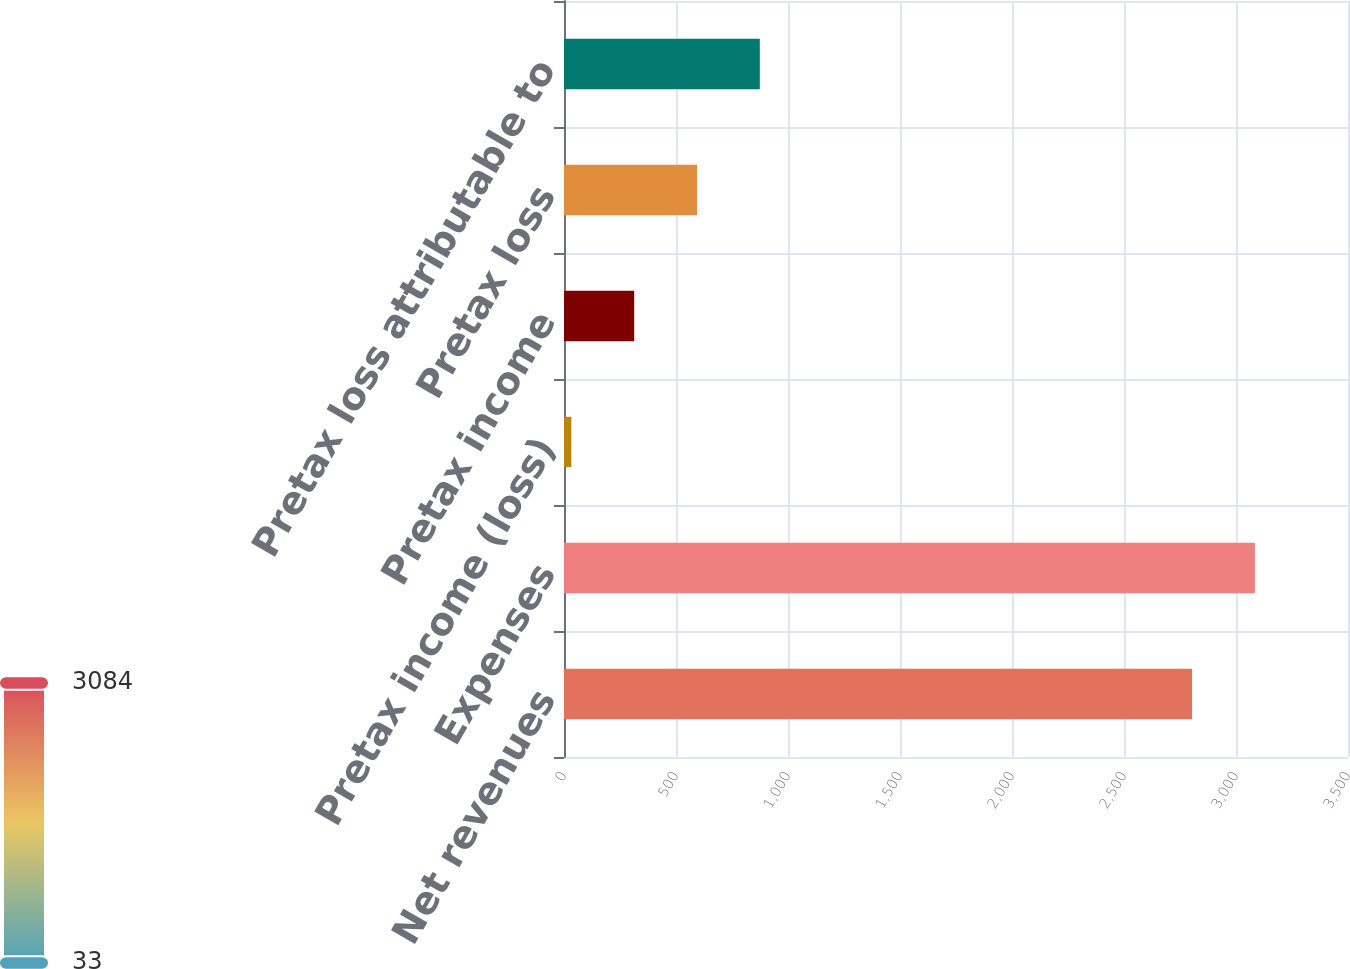<chart> <loc_0><loc_0><loc_500><loc_500><bar_chart><fcel>Net revenues<fcel>Expenses<fcel>Pretax income (loss)<fcel>Pretax income<fcel>Pretax loss<fcel>Pretax loss attributable to<nl><fcel>2804<fcel>3084.4<fcel>33<fcel>313.4<fcel>593.8<fcel>874.2<nl></chart> 